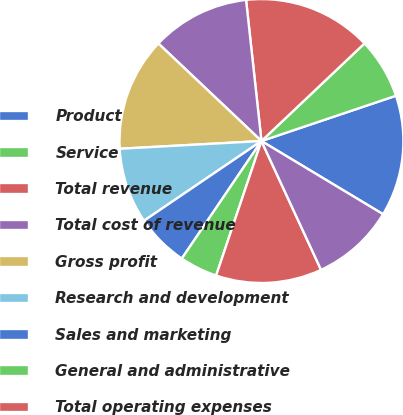<chart> <loc_0><loc_0><loc_500><loc_500><pie_chart><fcel>Product<fcel>Service<fcel>Total revenue<fcel>Total cost of revenue<fcel>Gross profit<fcel>Research and development<fcel>Sales and marketing<fcel>General and administrative<fcel>Total operating expenses<fcel>Income from operations<nl><fcel>13.79%<fcel>6.9%<fcel>14.66%<fcel>11.21%<fcel>12.93%<fcel>8.62%<fcel>6.03%<fcel>4.31%<fcel>12.07%<fcel>9.48%<nl></chart> 